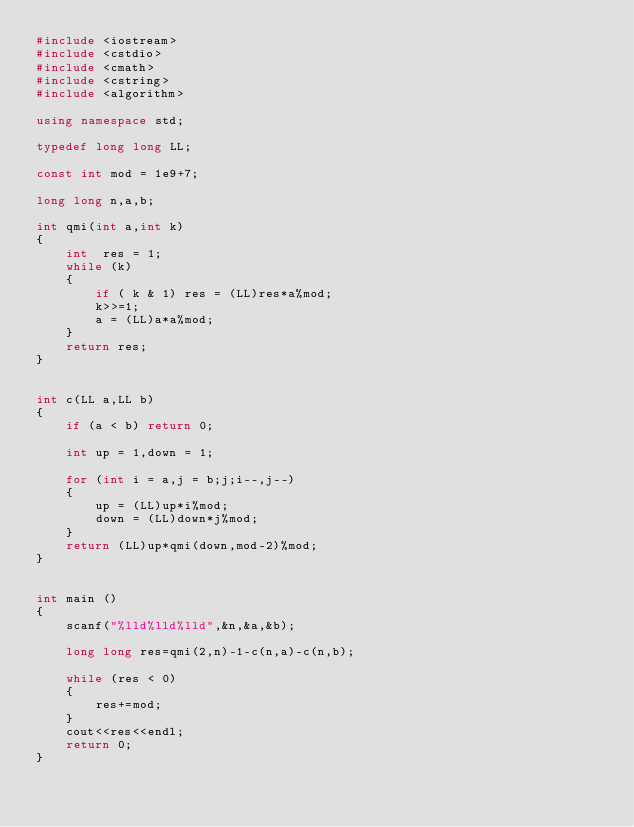<code> <loc_0><loc_0><loc_500><loc_500><_C++_>#include <iostream>
#include <cstdio>
#include <cmath>
#include <cstring>
#include <algorithm>

using namespace std;

typedef long long LL;

const int mod = 1e9+7;

long long n,a,b;

int qmi(int a,int k)
{
    int  res = 1;
    while (k)
    {
        if ( k & 1) res = (LL)res*a%mod;
        k>>=1;
        a = (LL)a*a%mod;
    }
    return res;
}


int c(LL a,LL b)
{
    if (a < b) return 0;
    
    int up = 1,down = 1;
    
    for (int i = a,j = b;j;i--,j--)
    {
        up = (LL)up*i%mod;
        down = (LL)down*j%mod;
    }
    return (LL)up*qmi(down,mod-2)%mod;
}


int main ()
{
    scanf("%lld%lld%lld",&n,&a,&b);
    
    long long res=qmi(2,n)-1-c(n,a)-c(n,b);
    
    while (res < 0)
    {
        res+=mod;
    }
    cout<<res<<endl;
    return 0;
}
</code> 